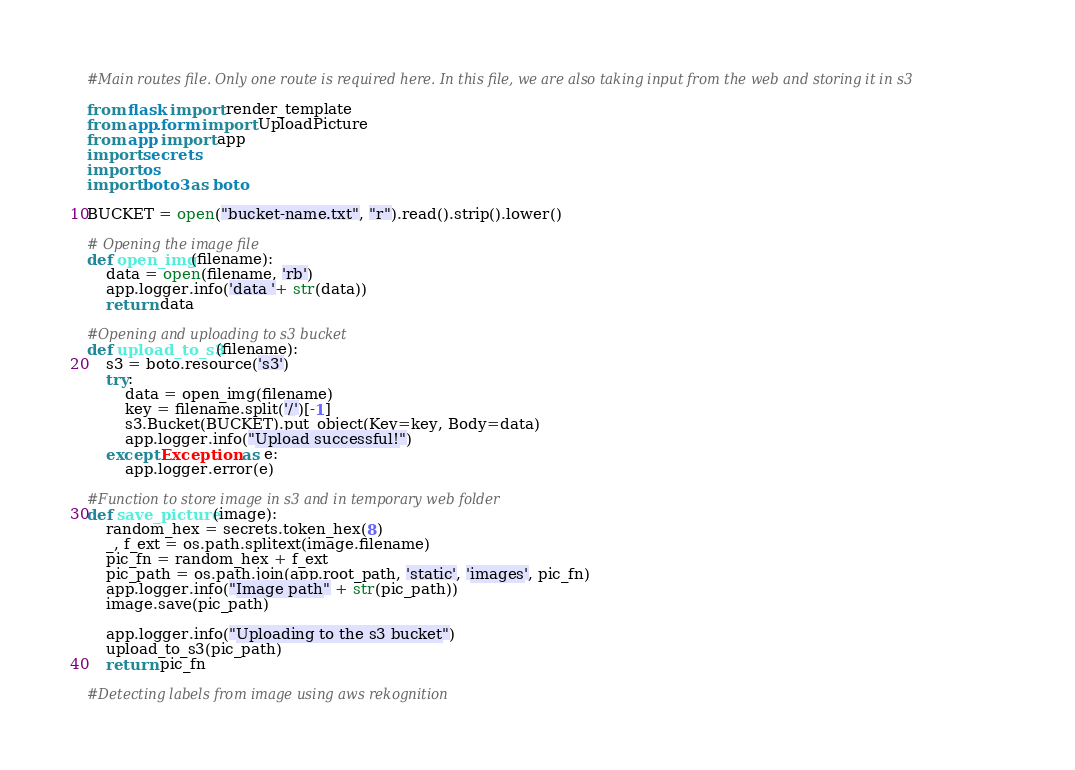<code> <loc_0><loc_0><loc_500><loc_500><_Python_>#Main routes file. Only one route is required here. In this file, we are also taking input from the web and storing it in s3

from flask import render_template
from app.form import UploadPicture
from app import app
import secrets
import os
import boto3 as boto

BUCKET = open("bucket-name.txt", "r").read().strip().lower()

# Opening the image file
def open_img(filename):
    data = open(filename, 'rb')
    app.logger.info('data '+ str(data))
    return data

#Opening and uploading to s3 bucket
def upload_to_s3(filename):
    s3 = boto.resource('s3')
    try:
        data = open_img(filename)
        key = filename.split('/')[-1]
        s3.Bucket(BUCKET).put_object(Key=key, Body=data)
        app.logger.info("Upload successful!")
    except Exception as e:
        app.logger.error(e)

#Function to store image in s3 and in temporary web folder
def save_picture(image):
    random_hex = secrets.token_hex(8)
    _, f_ext = os.path.splitext(image.filename)
    pic_fn = random_hex + f_ext
    pic_path = os.path.join(app.root_path, 'static', 'images', pic_fn)
    app.logger.info("Image path" + str(pic_path))
    image.save(pic_path)

    app.logger.info("Uploading to the s3 bucket")
    upload_to_s3(pic_path)
    return pic_fn

#Detecting labels from image using aws rekognition</code> 